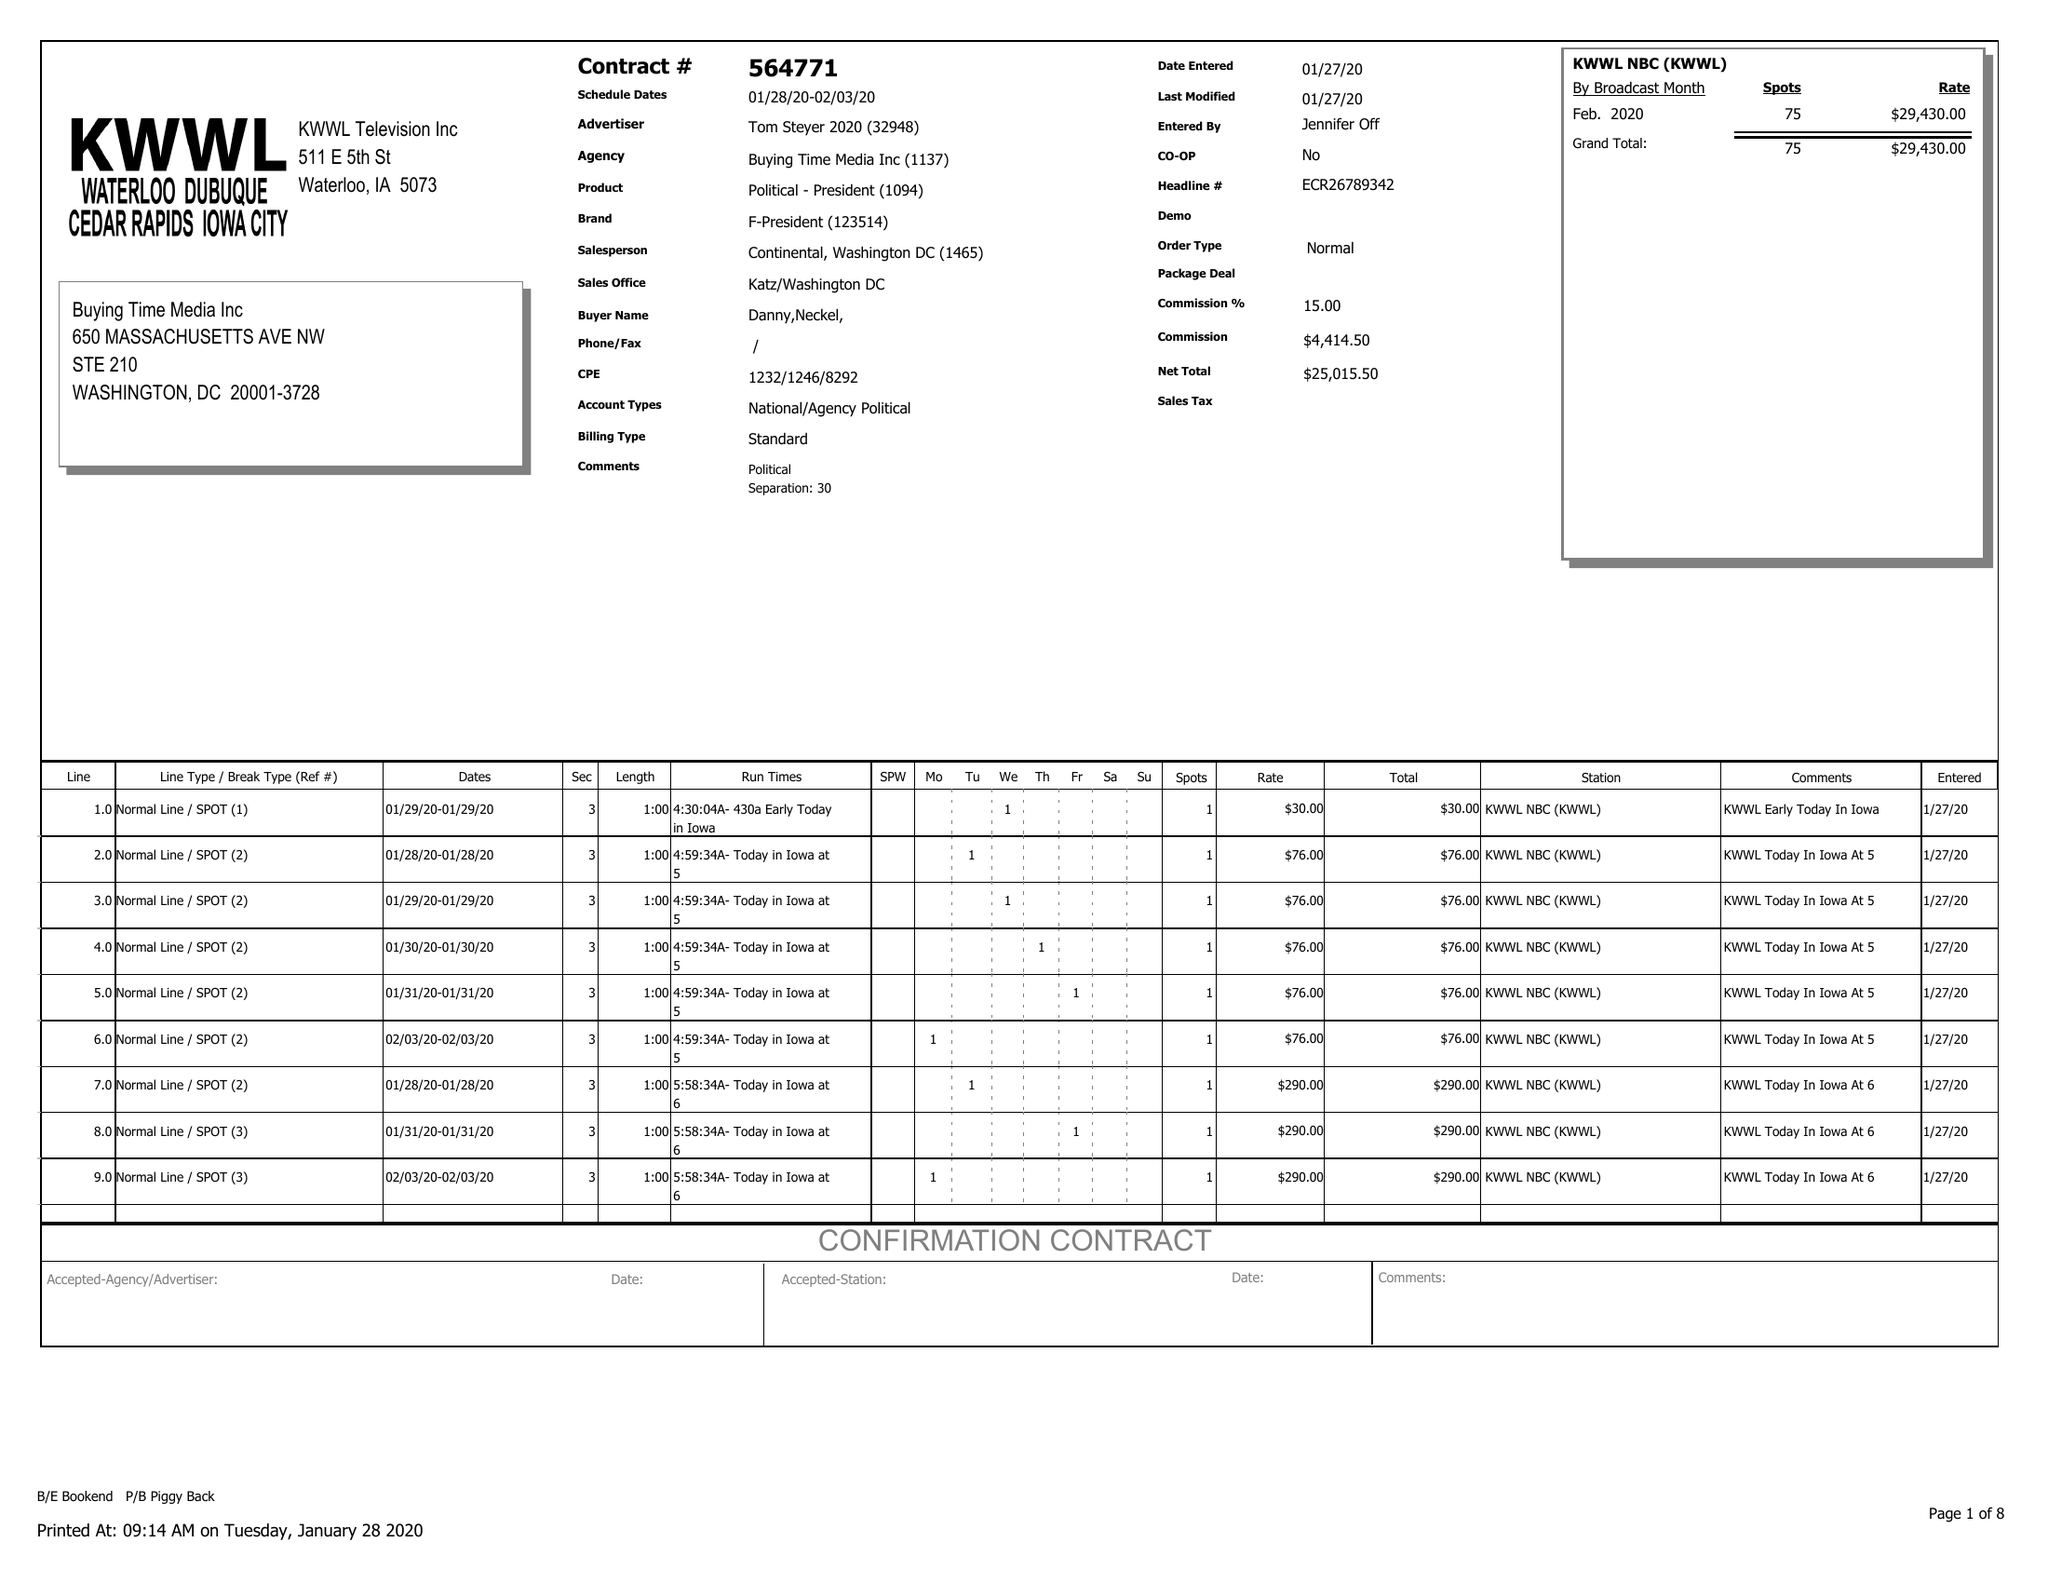What is the value for the flight_to?
Answer the question using a single word or phrase. 02/03/20 